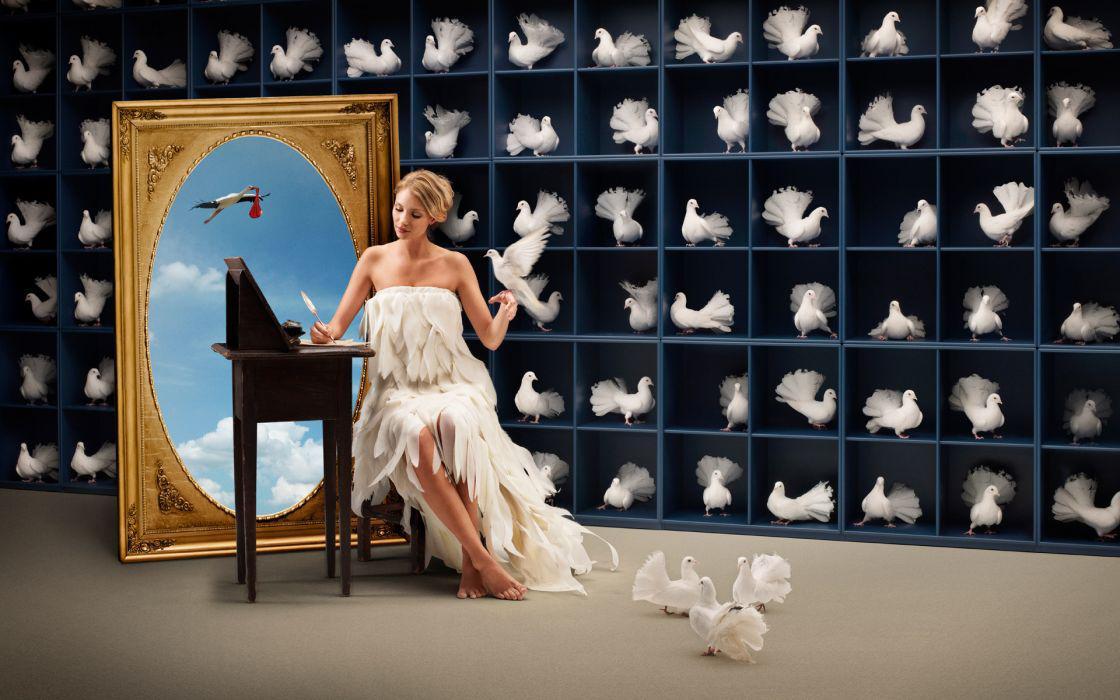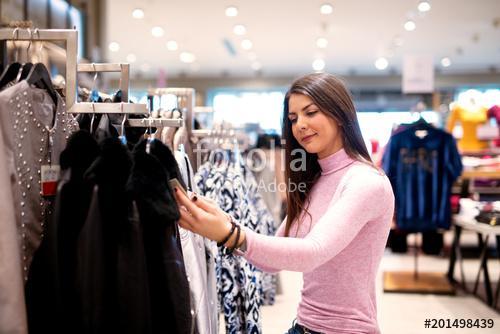The first image is the image on the left, the second image is the image on the right. Assess this claim about the two images: "The left and right image contains the same number of women.". Correct or not? Answer yes or no. Yes. 